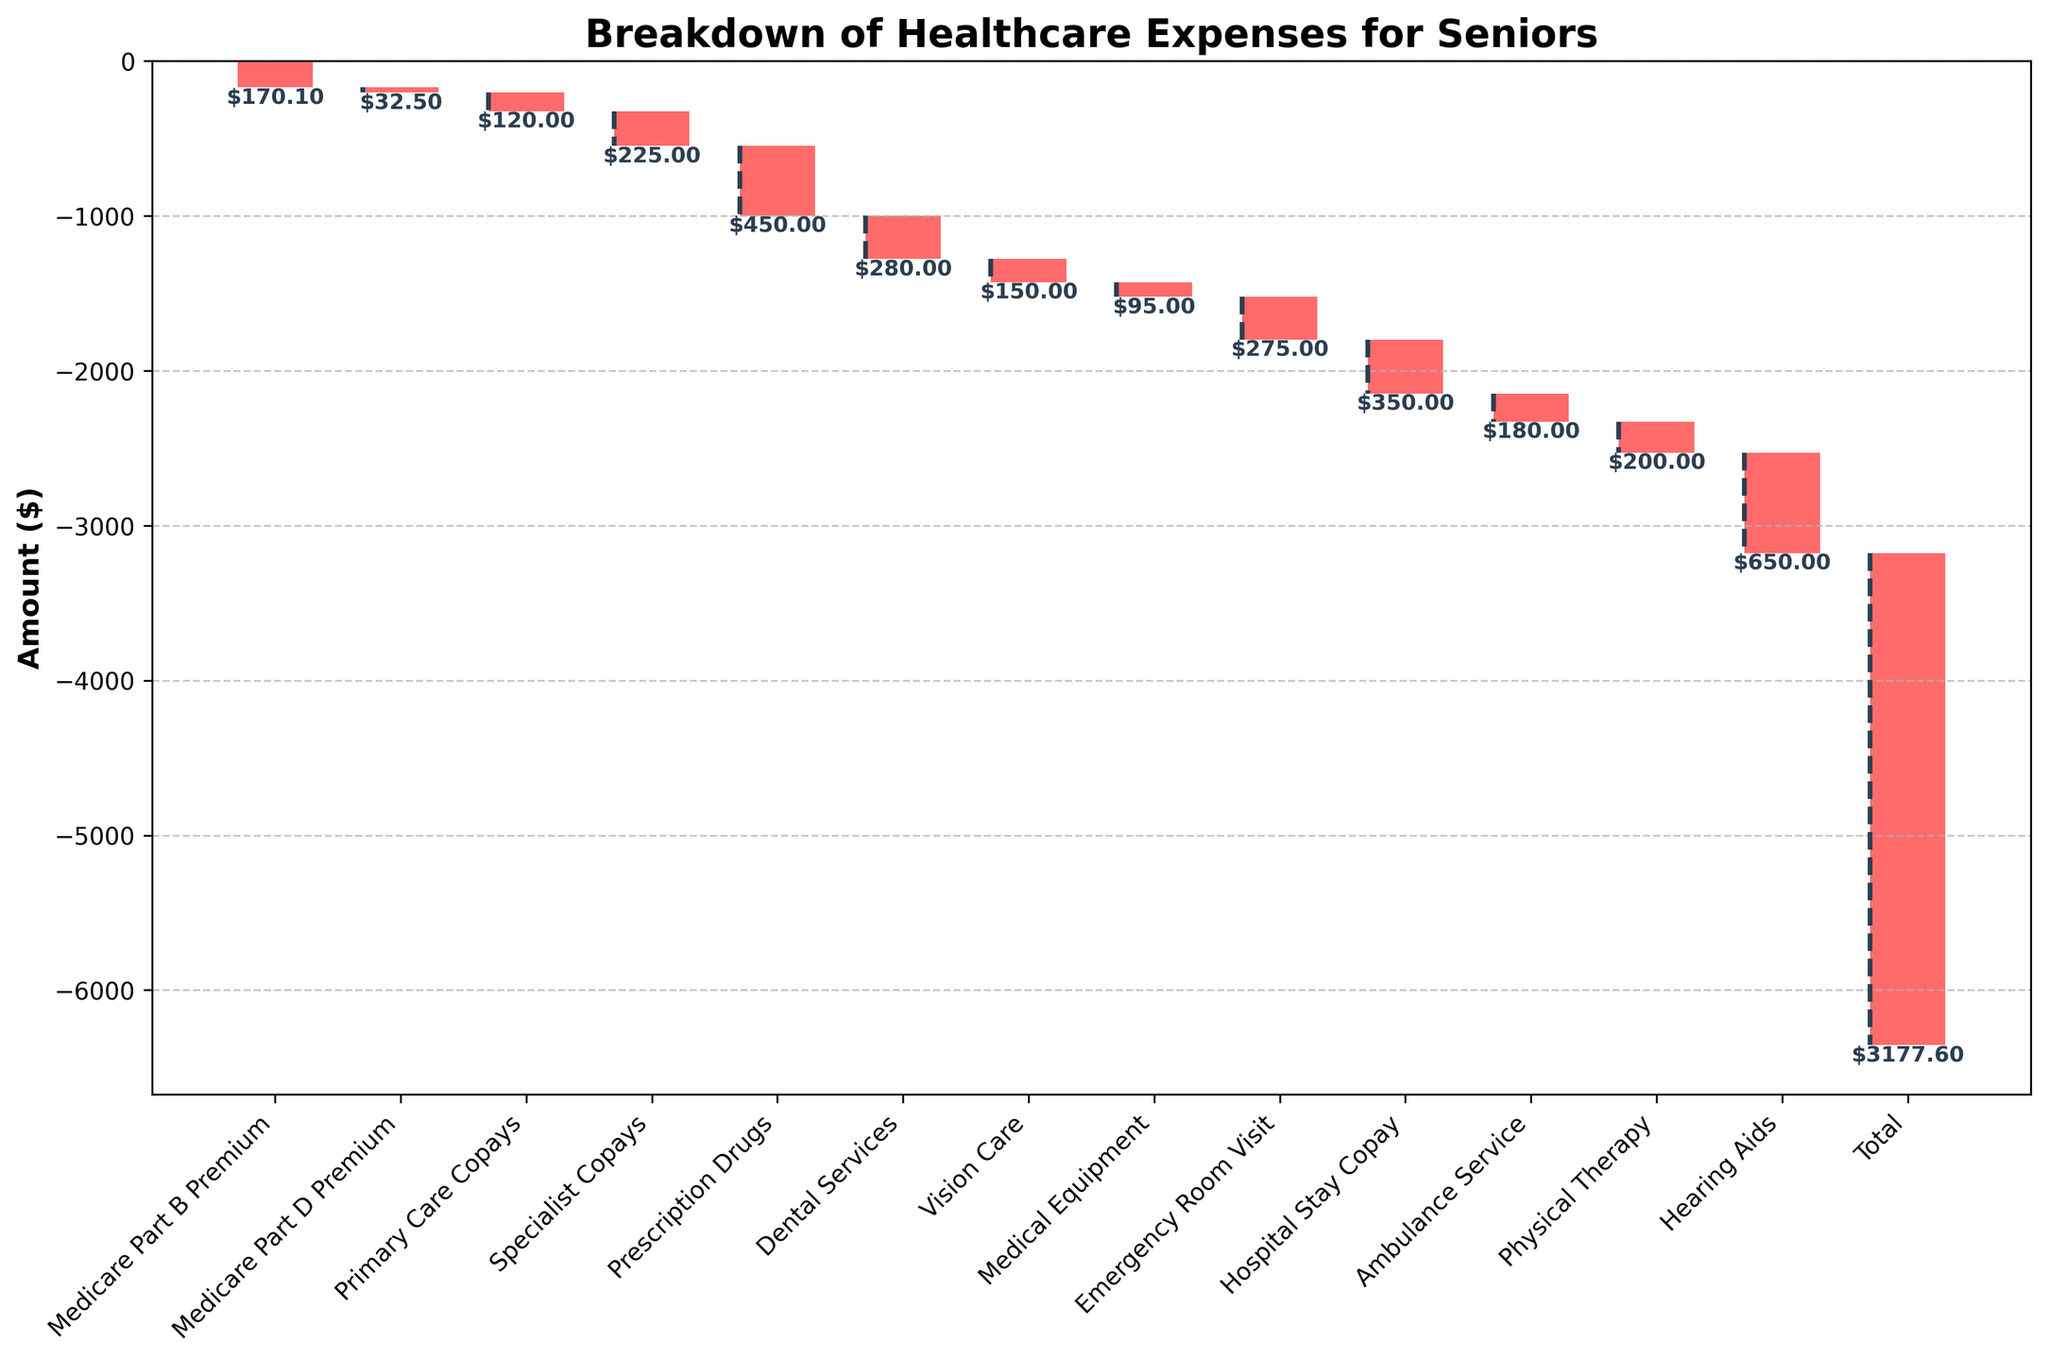What is the title of the chart? The title is written at the top of the chart, providing an overview of the content. It reads "Breakdown of Healthcare Expenses for Seniors".
Answer: Breakdown of Healthcare Expenses for Seniors How many categories are shown in the chart? Each bar represents a category, and you can count them by looking at the x-axis labels. There are a total of 14 categories (including "Total").
Answer: 14 What is the largest single expense category in the chart? By comparing the heights of the bars, the largest expense category is the one corresponding to the tallest bar, which is "Hearing Aids".
Answer: Hearing Aids Which category has the smallest expenditure? The smallest expense is identified by the shortest bar which is "Medicare Part D Premium".
Answer: Medicare Part D Premium How much do the "Primary Care Copays" and "Specialist Copays" together contribute to the total expenses? Add the amounts of "Primary Care Copays" (-120.00) and "Specialist Copays" (-225.00). The total is -120.00 - 225.00 = -345.00.
Answer: -345.00 What is the amount spent on "Hospital Stay Copay"? Find the bar labeled "Hospital Stay Copay" and read its value, which is -350.00.
Answer: -350.00 Which is greater, the amount spent on "Dental Services" or "Vision Care"? Compare the heights of the bars for "Dental Services" (-280.00) and "Vision Care" (-150.00). "Dental Services" has the higher expenditure.
Answer: Dental Services What is the difference between the total amount spent on "Prescription Drugs" and "Emergency Room Visit"? Subtract "Emergency Room Visit" (-275.00) from "Prescription Drugs" (-450.00). The difference is -450.00 - (-275.00) = -175.00.
Answer: -175.00 What portion of the total expenses is covered by "Medicare Part B Premium" and "Medicare Part D Premium"? Add the amounts of "Medicare Part B Premium" (-170.10) and "Medicare Part D Premium" (-32.50). The sum is -170.10 - 32.50 = -202.60.
Answer: -202.60 What categories are depicted as having amounts less than -200.00? Identify the bars with values less than -200.00. They include "Specialist Copays", "Prescription Drugs", "Dental Services", "Emergency Room Visit", "Hospital Stay Copay", "Physical Therapy", and "Hearing Aids".
Answer: Specialist Copays, Prescription Drugs, Dental Services, Emergency Room Visit, Hospital Stay Copay, Physical Therapy, Hearing Aids 